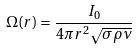Convert formula to latex. <formula><loc_0><loc_0><loc_500><loc_500>\Omega ( r ) = \frac { I _ { 0 } } { 4 \pi r ^ { 2 } \sqrt { \sigma \rho \nu } }</formula> 